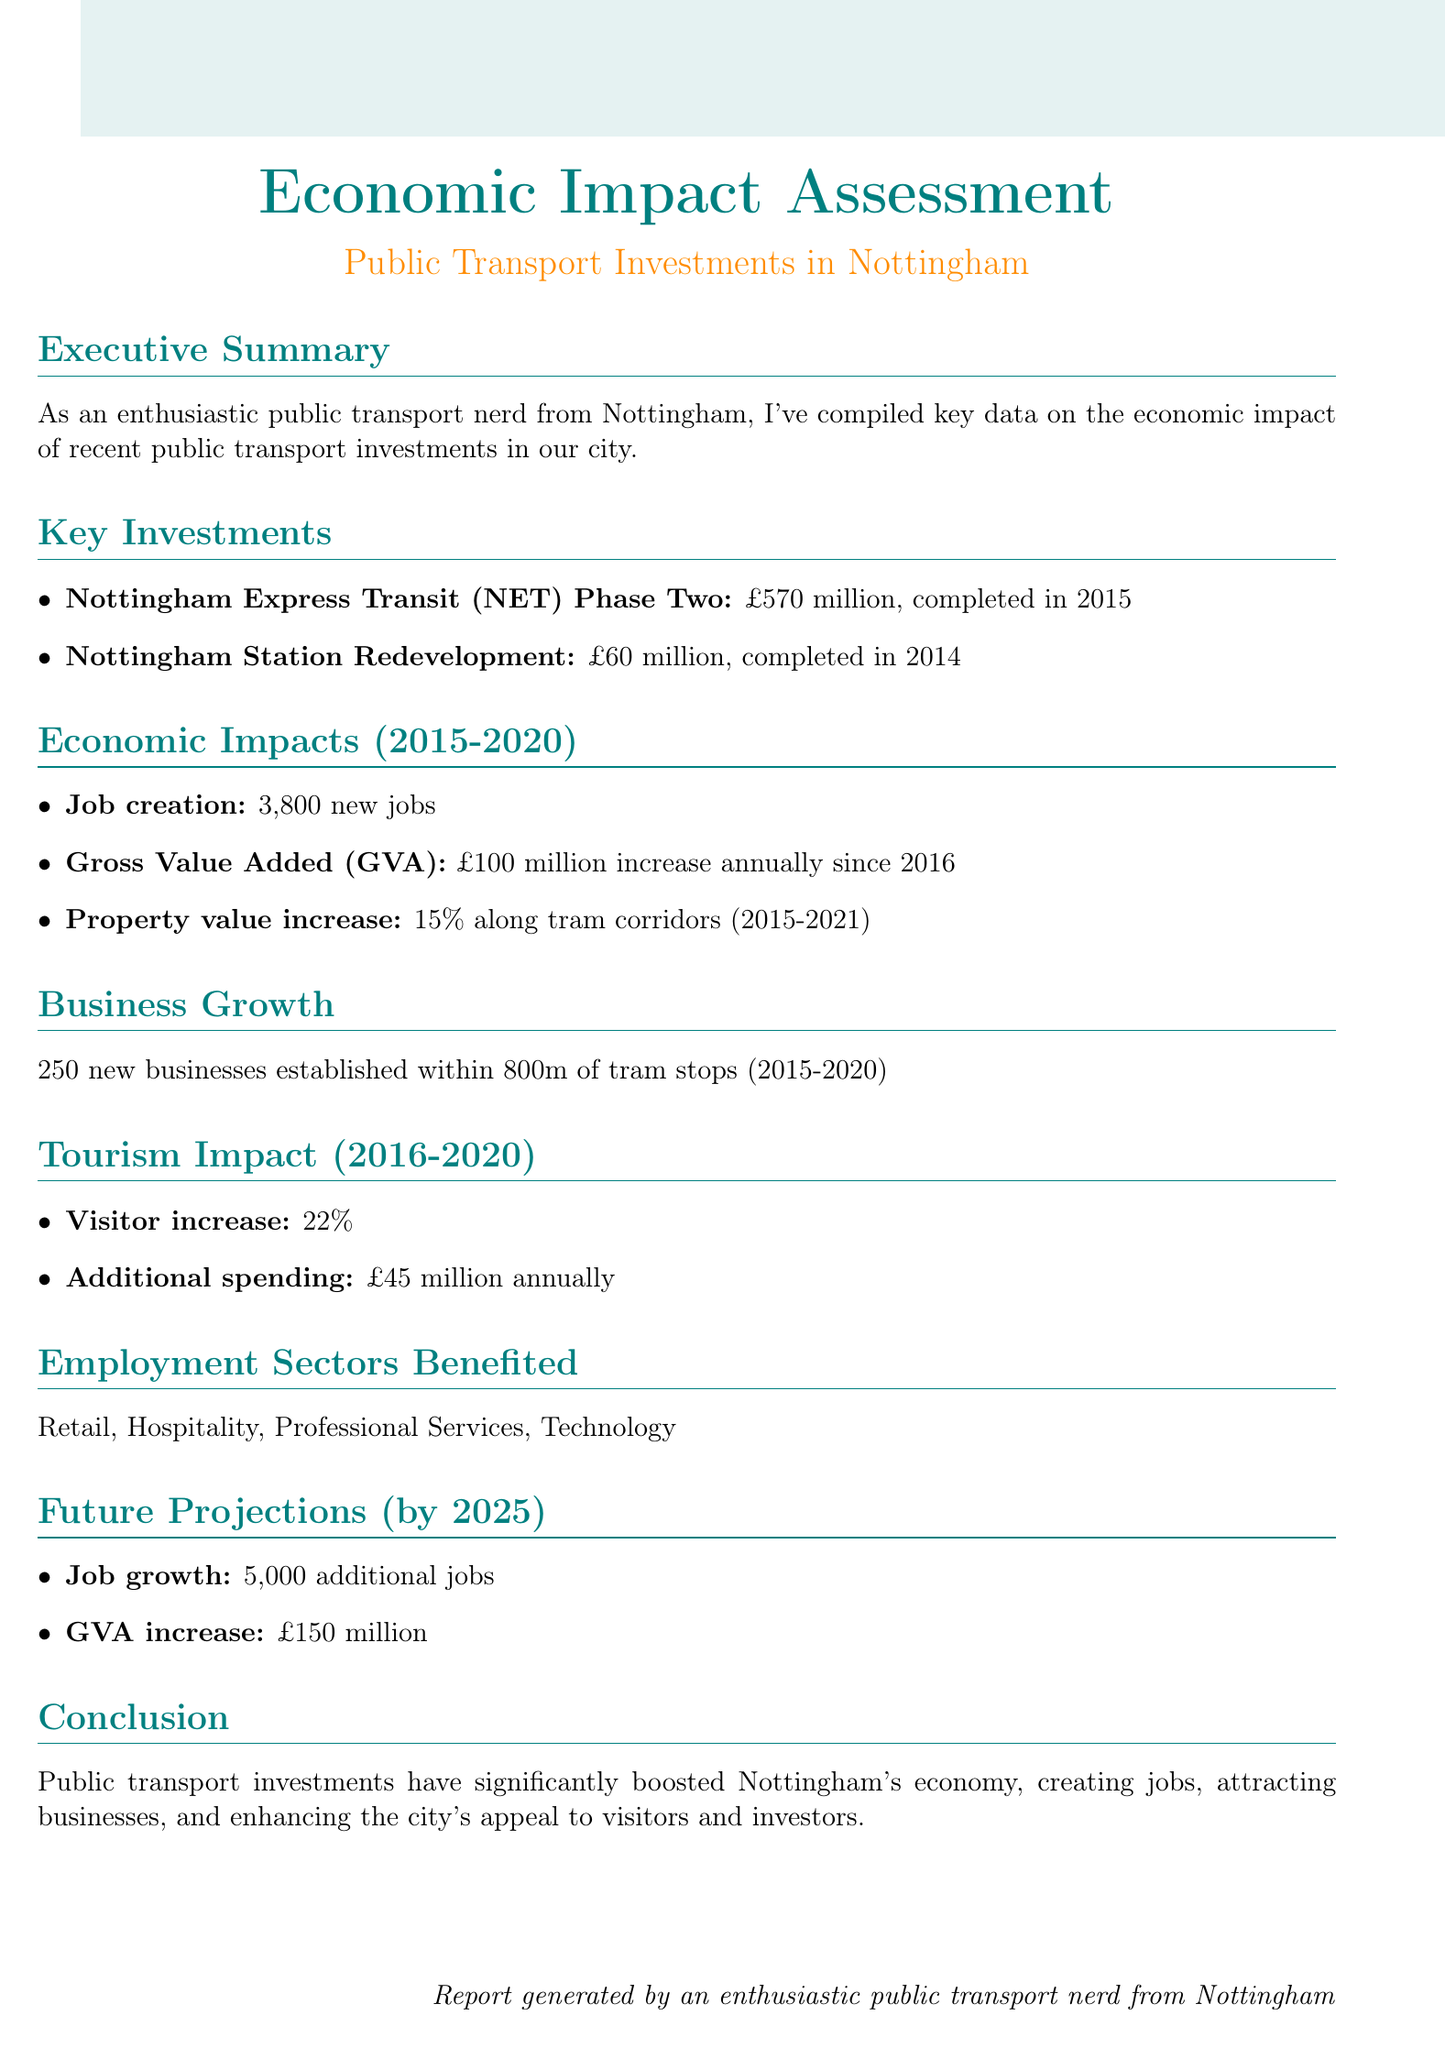What was the cost of the Nottingham Express Transit Phase Two? The cost of the Nottingham Express Transit Phase Two is provided under key investments in the document.
Answer: £570 million How many new jobs were created from 2015 to 2020? The document states the number of new jobs created in the economic impacts section.
Answer: 3,800 new jobs What was the increase in Gross Value Added since 2016? The GVA increase is mentioned under economic impacts as an annual figure.
Answer: £100 million How many new businesses were established within 800m of tram stops? This information is provided in the business growth section of the document.
Answer: 250 What was the percentage increase in visitors from 2016 to 2020? The visitor increase is highlighted in the tourism impact section.
Answer: 22% What is the projected job growth by 2025? The future projections section outlines the expected job growth.
Answer: 5,000 additional jobs What was the additional spending from tourism annually during 2016 to 2020? This figure is provided in the tourism impact section regarding additional spending.
Answer: £45 million annually Which sectors benefited from the public transport investments? The document lists the benefited sectors in the employment sectors benefited section.
Answer: Retail, Hospitality, Professional Services, Technology What is the completion year of the Nottingham Station Redevelopment? This information is found in the key investments section detailing project completion years.
Answer: 2014 